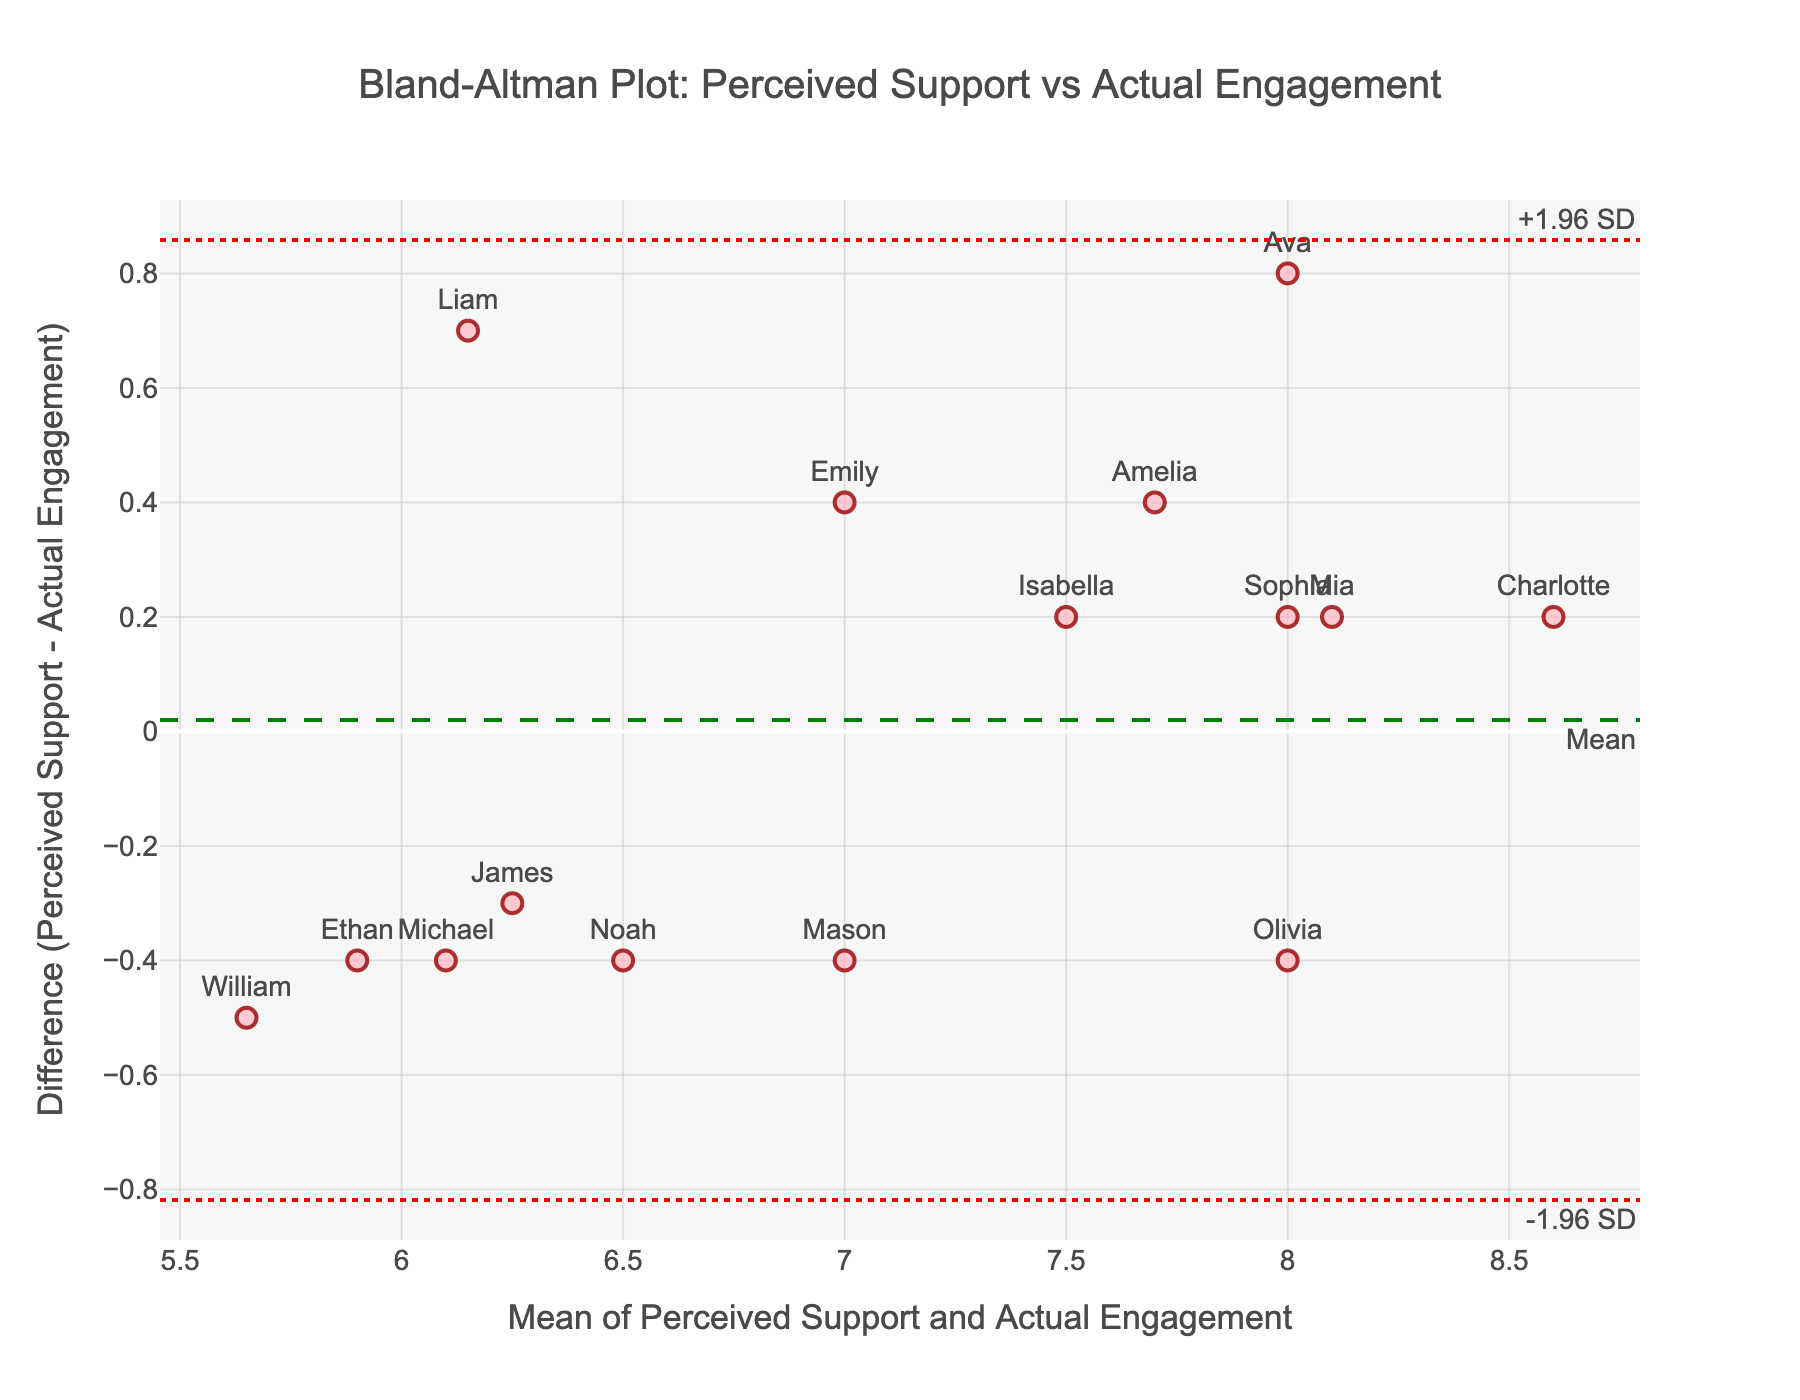What is the title of the plot? The title is located at the top of the plot and reads "Bland-Altman Plot: Perceived Support vs Actual Engagement".
Answer: Bland-Altman Plot: Perceived Support vs Actual Engagement How many data points are shown in the plot? There is one marker for each member, and there are 15 members listed in the provided data. Therefore, the plot has 15 data points.
Answer: 15 What is the mean difference between Perceived Support and Actual Engagement? The mean difference is represented by a horizontal dashed green line on the plot.
Answer: 0.12 What are the upper and lower Limits of Agreement (LOA) in the plot? The upper LOA is indicated by a dotted red line at 0.96, and the lower LOA is indicated by another dotted red line at -0.72.
Answer: 0.96 and -0.72 What is the y-axis title in the plot? The y-axis is labeled as "Difference (Perceived Support - Actual Engagement)".
Answer: Difference (Perceived Support - Actual Engagement) What is the x-axis title in the plot? The x-axis is labeled as "Mean of Perceived Support and Actual Engagement".
Answer: Mean of Perceived Support and Actual Engagement Which member has the highest difference between Perceived Support and Actual Engagement? The member with the highest difference can be found at the highest point on the y-axis. Charlotte is at the highest y-value.
Answer: Charlotte Which member has the lowest difference between Perceived Support and Actual Engagement? The member with the lowest difference can be found at the lowest point on the y-axis. Liam is at the lowest y-value.
Answer: Liam What is the range of the differences (from the lowest to the highest) between Perceived Support and Actual Engagement? To find the range, identify the lowest and highest y-values. The lowest is around -0.8 (Liam), and the highest is around 0.8 (Charlotte). The range is the difference: 0.8 - (-0.8) = 1.6.
Answer: 1.6 